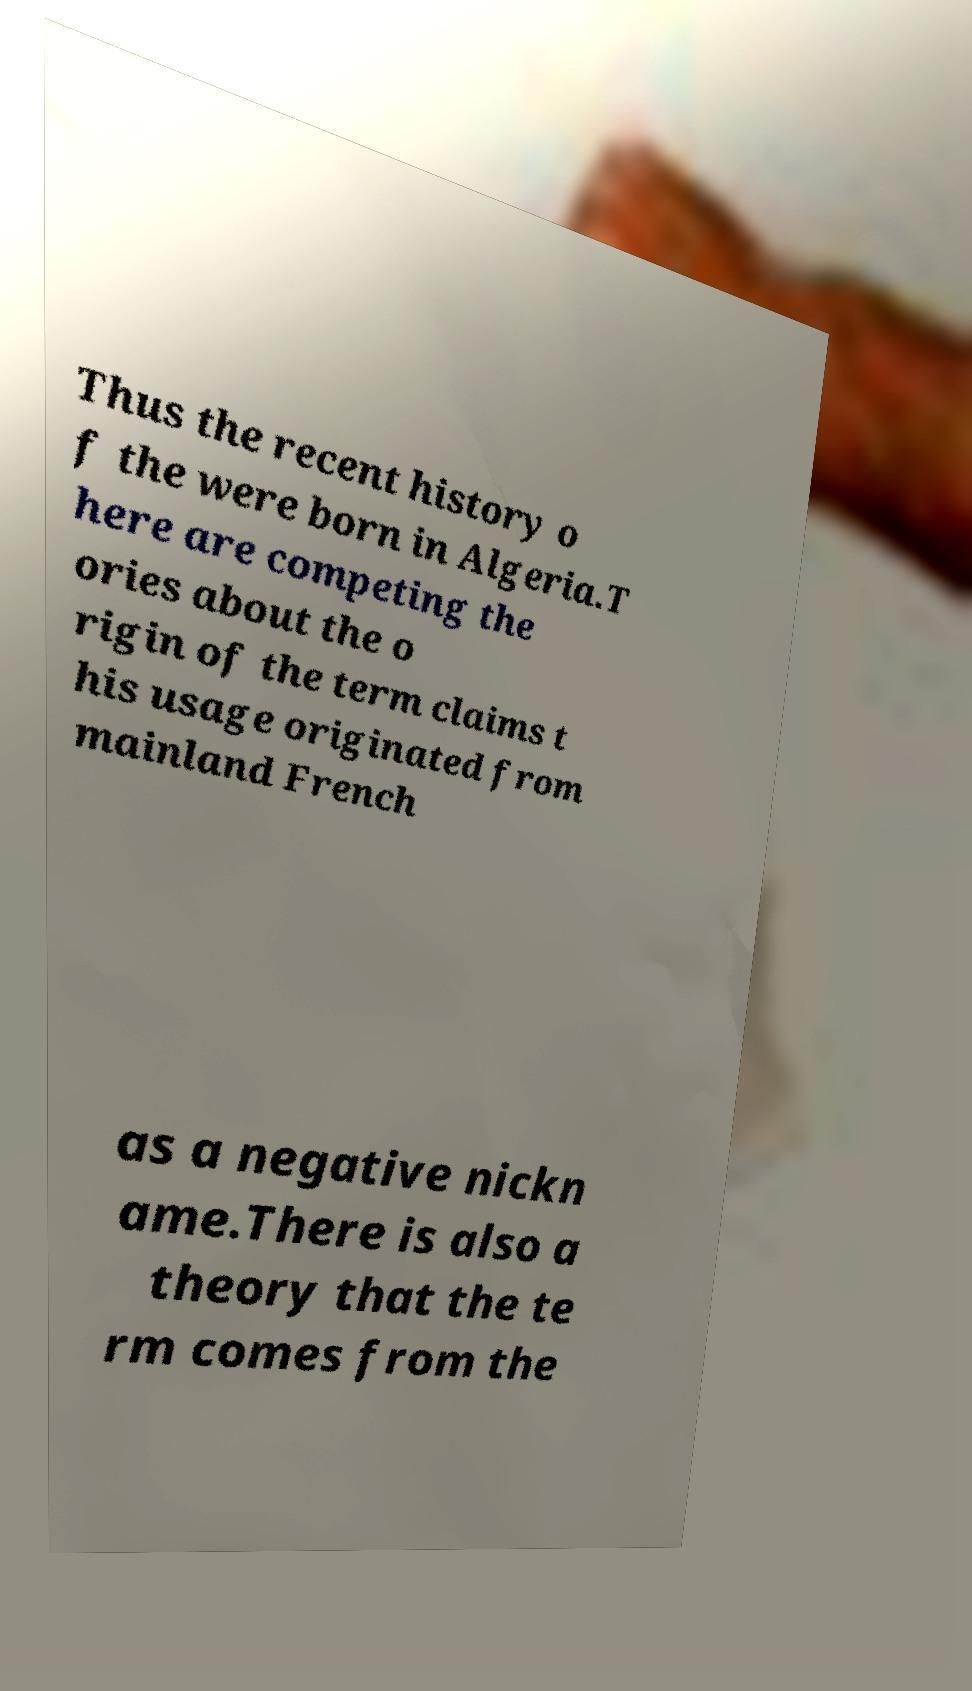What messages or text are displayed in this image? I need them in a readable, typed format. Thus the recent history o f the were born in Algeria.T here are competing the ories about the o rigin of the term claims t his usage originated from mainland French as a negative nickn ame.There is also a theory that the te rm comes from the 